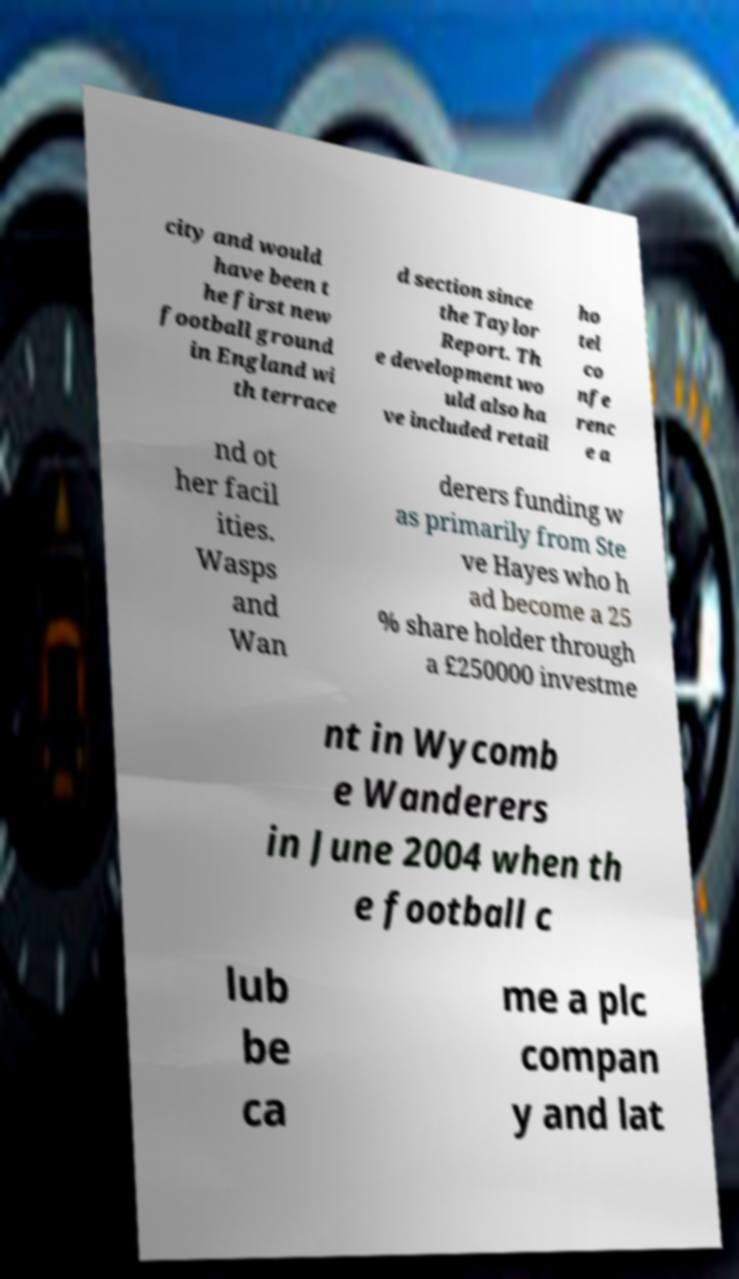What messages or text are displayed in this image? I need them in a readable, typed format. city and would have been t he first new football ground in England wi th terrace d section since the Taylor Report. Th e development wo uld also ha ve included retail ho tel co nfe renc e a nd ot her facil ities. Wasps and Wan derers funding w as primarily from Ste ve Hayes who h ad become a 25 % share holder through a £250000 investme nt in Wycomb e Wanderers in June 2004 when th e football c lub be ca me a plc compan y and lat 